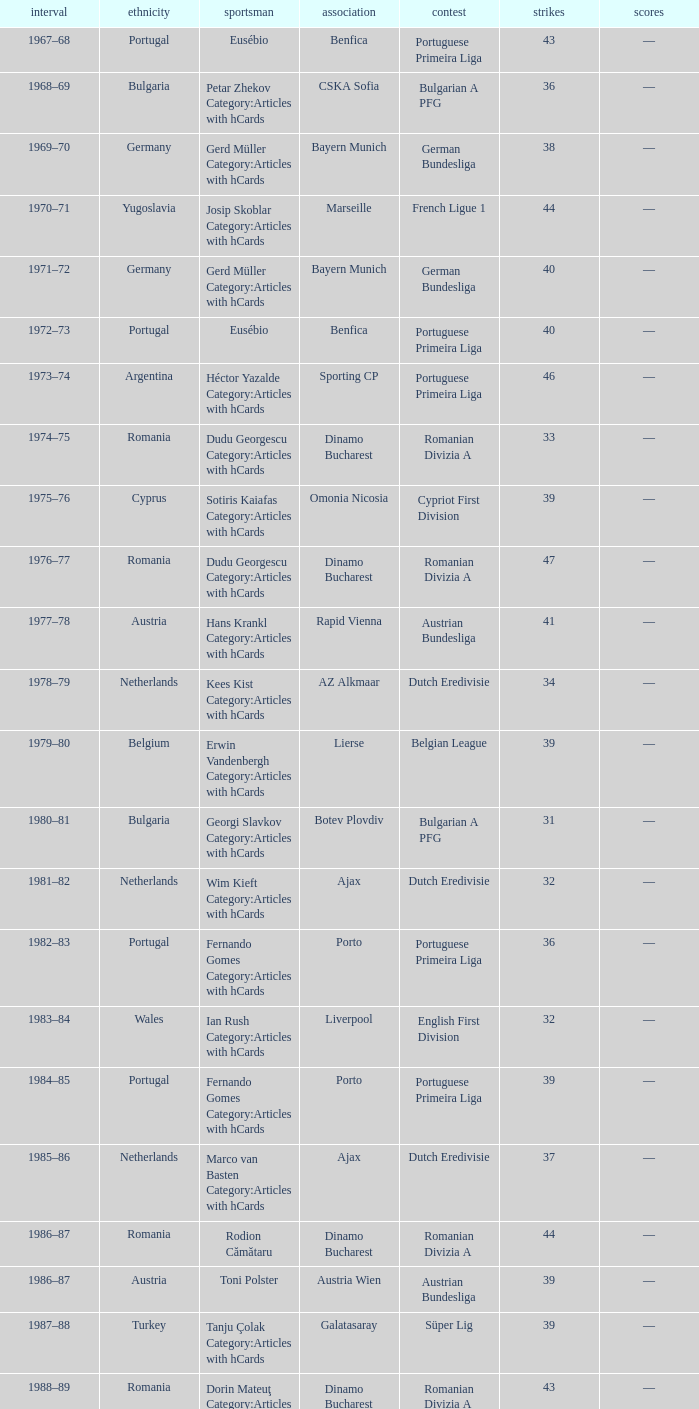Which league's nationality was Italy when there were 62 points? Italian Serie A. 